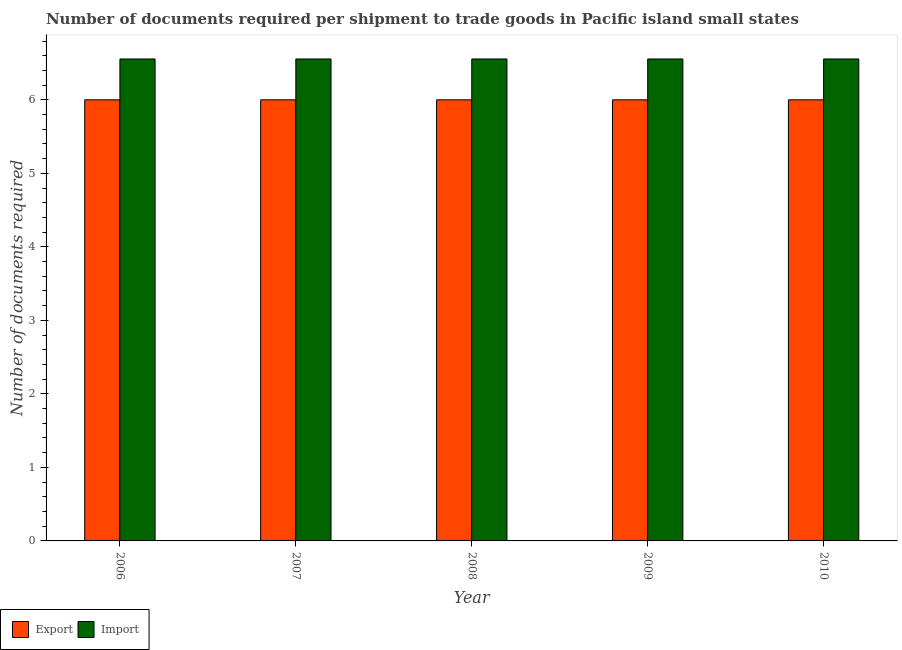How many different coloured bars are there?
Provide a succinct answer. 2. How many groups of bars are there?
Offer a terse response. 5. How many bars are there on the 3rd tick from the left?
Provide a short and direct response. 2. What is the label of the 3rd group of bars from the left?
Offer a very short reply. 2008. In how many cases, is the number of bars for a given year not equal to the number of legend labels?
Give a very brief answer. 0. What is the number of documents required to import goods in 2006?
Keep it short and to the point. 6.56. Across all years, what is the maximum number of documents required to import goods?
Your answer should be very brief. 6.56. Across all years, what is the minimum number of documents required to import goods?
Your response must be concise. 6.56. In which year was the number of documents required to export goods maximum?
Ensure brevity in your answer.  2006. What is the total number of documents required to import goods in the graph?
Provide a succinct answer. 32.78. What is the difference between the number of documents required to export goods in 2008 and that in 2010?
Your response must be concise. 0. What is the average number of documents required to import goods per year?
Provide a short and direct response. 6.56. In how many years, is the number of documents required to import goods greater than 3?
Keep it short and to the point. 5. Is the number of documents required to import goods in 2006 less than that in 2007?
Give a very brief answer. No. Is the sum of the number of documents required to import goods in 2007 and 2010 greater than the maximum number of documents required to export goods across all years?
Your answer should be very brief. Yes. What does the 2nd bar from the left in 2007 represents?
Offer a very short reply. Import. What does the 2nd bar from the right in 2006 represents?
Give a very brief answer. Export. How many bars are there?
Offer a very short reply. 10. Are all the bars in the graph horizontal?
Provide a short and direct response. No. What is the difference between two consecutive major ticks on the Y-axis?
Offer a terse response. 1. How many legend labels are there?
Keep it short and to the point. 2. What is the title of the graph?
Provide a succinct answer. Number of documents required per shipment to trade goods in Pacific island small states. Does "Fertility rate" appear as one of the legend labels in the graph?
Ensure brevity in your answer.  No. What is the label or title of the X-axis?
Keep it short and to the point. Year. What is the label or title of the Y-axis?
Your answer should be compact. Number of documents required. What is the Number of documents required of Export in 2006?
Provide a succinct answer. 6. What is the Number of documents required in Import in 2006?
Offer a very short reply. 6.56. What is the Number of documents required in Export in 2007?
Provide a succinct answer. 6. What is the Number of documents required in Import in 2007?
Make the answer very short. 6.56. What is the Number of documents required in Export in 2008?
Give a very brief answer. 6. What is the Number of documents required in Import in 2008?
Provide a short and direct response. 6.56. What is the Number of documents required of Import in 2009?
Your answer should be compact. 6.56. What is the Number of documents required of Import in 2010?
Offer a very short reply. 6.56. Across all years, what is the maximum Number of documents required of Export?
Offer a very short reply. 6. Across all years, what is the maximum Number of documents required in Import?
Provide a succinct answer. 6.56. Across all years, what is the minimum Number of documents required in Export?
Your answer should be compact. 6. Across all years, what is the minimum Number of documents required in Import?
Offer a very short reply. 6.56. What is the total Number of documents required of Import in the graph?
Make the answer very short. 32.78. What is the difference between the Number of documents required in Import in 2006 and that in 2007?
Ensure brevity in your answer.  0. What is the difference between the Number of documents required in Import in 2006 and that in 2008?
Ensure brevity in your answer.  0. What is the difference between the Number of documents required of Import in 2006 and that in 2009?
Make the answer very short. 0. What is the difference between the Number of documents required in Export in 2006 and that in 2010?
Keep it short and to the point. 0. What is the difference between the Number of documents required of Export in 2007 and that in 2008?
Your response must be concise. 0. What is the difference between the Number of documents required of Import in 2007 and that in 2010?
Your response must be concise. 0. What is the difference between the Number of documents required in Export in 2008 and that in 2009?
Provide a succinct answer. 0. What is the difference between the Number of documents required in Export in 2008 and that in 2010?
Give a very brief answer. 0. What is the difference between the Number of documents required in Import in 2008 and that in 2010?
Make the answer very short. 0. What is the difference between the Number of documents required of Export in 2009 and that in 2010?
Your response must be concise. 0. What is the difference between the Number of documents required in Import in 2009 and that in 2010?
Provide a short and direct response. 0. What is the difference between the Number of documents required of Export in 2006 and the Number of documents required of Import in 2007?
Offer a terse response. -0.56. What is the difference between the Number of documents required in Export in 2006 and the Number of documents required in Import in 2008?
Your answer should be very brief. -0.56. What is the difference between the Number of documents required of Export in 2006 and the Number of documents required of Import in 2009?
Ensure brevity in your answer.  -0.56. What is the difference between the Number of documents required of Export in 2006 and the Number of documents required of Import in 2010?
Offer a terse response. -0.56. What is the difference between the Number of documents required in Export in 2007 and the Number of documents required in Import in 2008?
Provide a succinct answer. -0.56. What is the difference between the Number of documents required in Export in 2007 and the Number of documents required in Import in 2009?
Make the answer very short. -0.56. What is the difference between the Number of documents required in Export in 2007 and the Number of documents required in Import in 2010?
Your answer should be very brief. -0.56. What is the difference between the Number of documents required of Export in 2008 and the Number of documents required of Import in 2009?
Your response must be concise. -0.56. What is the difference between the Number of documents required in Export in 2008 and the Number of documents required in Import in 2010?
Your answer should be compact. -0.56. What is the difference between the Number of documents required of Export in 2009 and the Number of documents required of Import in 2010?
Make the answer very short. -0.56. What is the average Number of documents required of Import per year?
Offer a terse response. 6.56. In the year 2006, what is the difference between the Number of documents required in Export and Number of documents required in Import?
Provide a short and direct response. -0.56. In the year 2007, what is the difference between the Number of documents required of Export and Number of documents required of Import?
Provide a succinct answer. -0.56. In the year 2008, what is the difference between the Number of documents required of Export and Number of documents required of Import?
Provide a short and direct response. -0.56. In the year 2009, what is the difference between the Number of documents required of Export and Number of documents required of Import?
Keep it short and to the point. -0.56. In the year 2010, what is the difference between the Number of documents required of Export and Number of documents required of Import?
Your answer should be compact. -0.56. What is the ratio of the Number of documents required in Export in 2006 to that in 2008?
Your answer should be very brief. 1. What is the ratio of the Number of documents required in Import in 2006 to that in 2008?
Offer a very short reply. 1. What is the ratio of the Number of documents required of Import in 2006 to that in 2009?
Your response must be concise. 1. What is the ratio of the Number of documents required in Import in 2006 to that in 2010?
Give a very brief answer. 1. What is the ratio of the Number of documents required in Import in 2007 to that in 2008?
Offer a very short reply. 1. What is the ratio of the Number of documents required of Export in 2007 to that in 2009?
Ensure brevity in your answer.  1. What is the ratio of the Number of documents required of Import in 2007 to that in 2009?
Ensure brevity in your answer.  1. What is the ratio of the Number of documents required of Import in 2007 to that in 2010?
Provide a short and direct response. 1. What is the ratio of the Number of documents required of Import in 2008 to that in 2009?
Your answer should be very brief. 1. What is the ratio of the Number of documents required in Export in 2008 to that in 2010?
Your response must be concise. 1. What is the difference between the highest and the second highest Number of documents required in Export?
Your response must be concise. 0. What is the difference between the highest and the lowest Number of documents required of Export?
Your answer should be very brief. 0. What is the difference between the highest and the lowest Number of documents required of Import?
Keep it short and to the point. 0. 